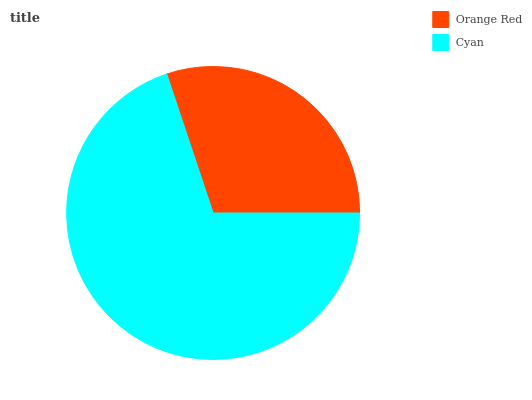Is Orange Red the minimum?
Answer yes or no. Yes. Is Cyan the maximum?
Answer yes or no. Yes. Is Cyan the minimum?
Answer yes or no. No. Is Cyan greater than Orange Red?
Answer yes or no. Yes. Is Orange Red less than Cyan?
Answer yes or no. Yes. Is Orange Red greater than Cyan?
Answer yes or no. No. Is Cyan less than Orange Red?
Answer yes or no. No. Is Cyan the high median?
Answer yes or no. Yes. Is Orange Red the low median?
Answer yes or no. Yes. Is Orange Red the high median?
Answer yes or no. No. Is Cyan the low median?
Answer yes or no. No. 